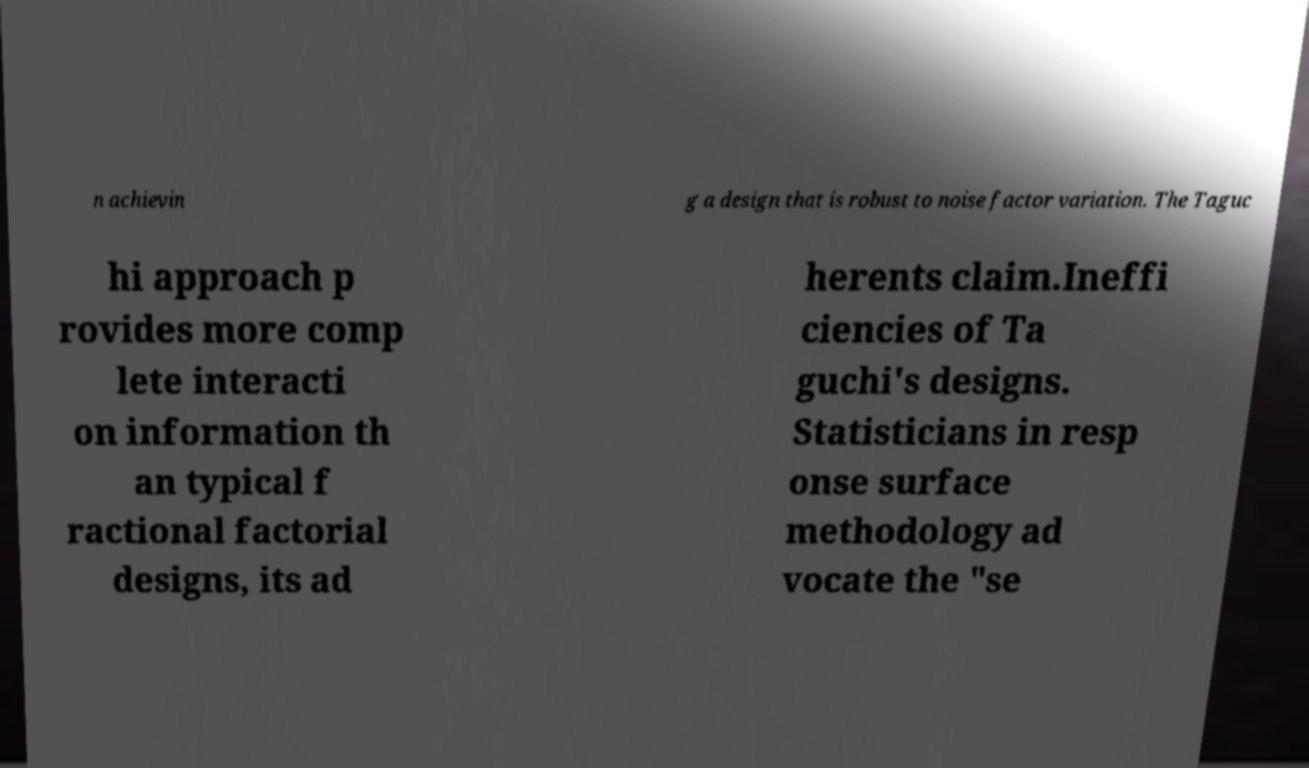What messages or text are displayed in this image? I need them in a readable, typed format. n achievin g a design that is robust to noise factor variation. The Taguc hi approach p rovides more comp lete interacti on information th an typical f ractional factorial designs, its ad herents claim.Ineffi ciencies of Ta guchi's designs. Statisticians in resp onse surface methodology ad vocate the "se 